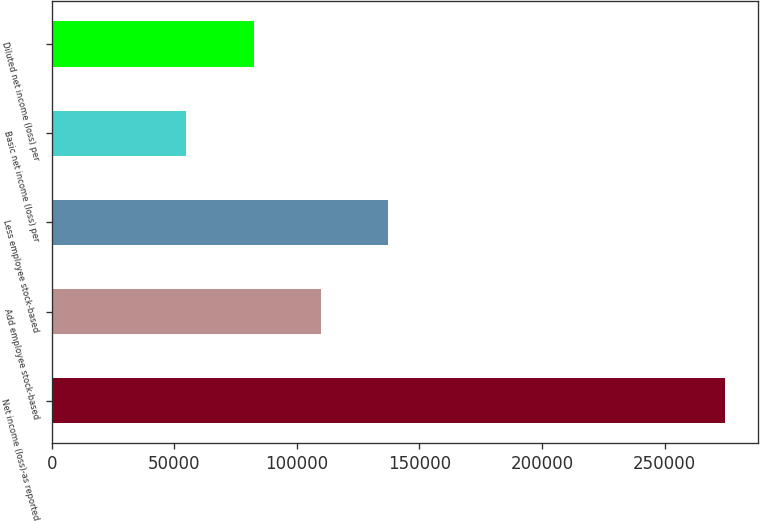Convert chart to OTSL. <chart><loc_0><loc_0><loc_500><loc_500><bar_chart><fcel>Net income (loss)-as reported<fcel>Add employee stock-based<fcel>Less employee stock-based<fcel>Basic net income (loss) per<fcel>Diluted net income (loss) per<nl><fcel>274490<fcel>109796<fcel>137245<fcel>54898.6<fcel>82347.6<nl></chart> 